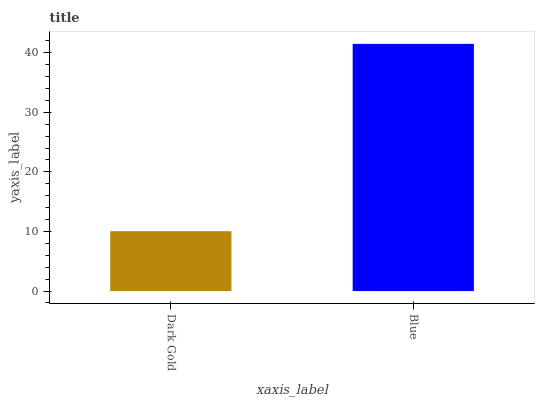Is Dark Gold the minimum?
Answer yes or no. Yes. Is Blue the maximum?
Answer yes or no. Yes. Is Blue the minimum?
Answer yes or no. No. Is Blue greater than Dark Gold?
Answer yes or no. Yes. Is Dark Gold less than Blue?
Answer yes or no. Yes. Is Dark Gold greater than Blue?
Answer yes or no. No. Is Blue less than Dark Gold?
Answer yes or no. No. Is Blue the high median?
Answer yes or no. Yes. Is Dark Gold the low median?
Answer yes or no. Yes. Is Dark Gold the high median?
Answer yes or no. No. Is Blue the low median?
Answer yes or no. No. 